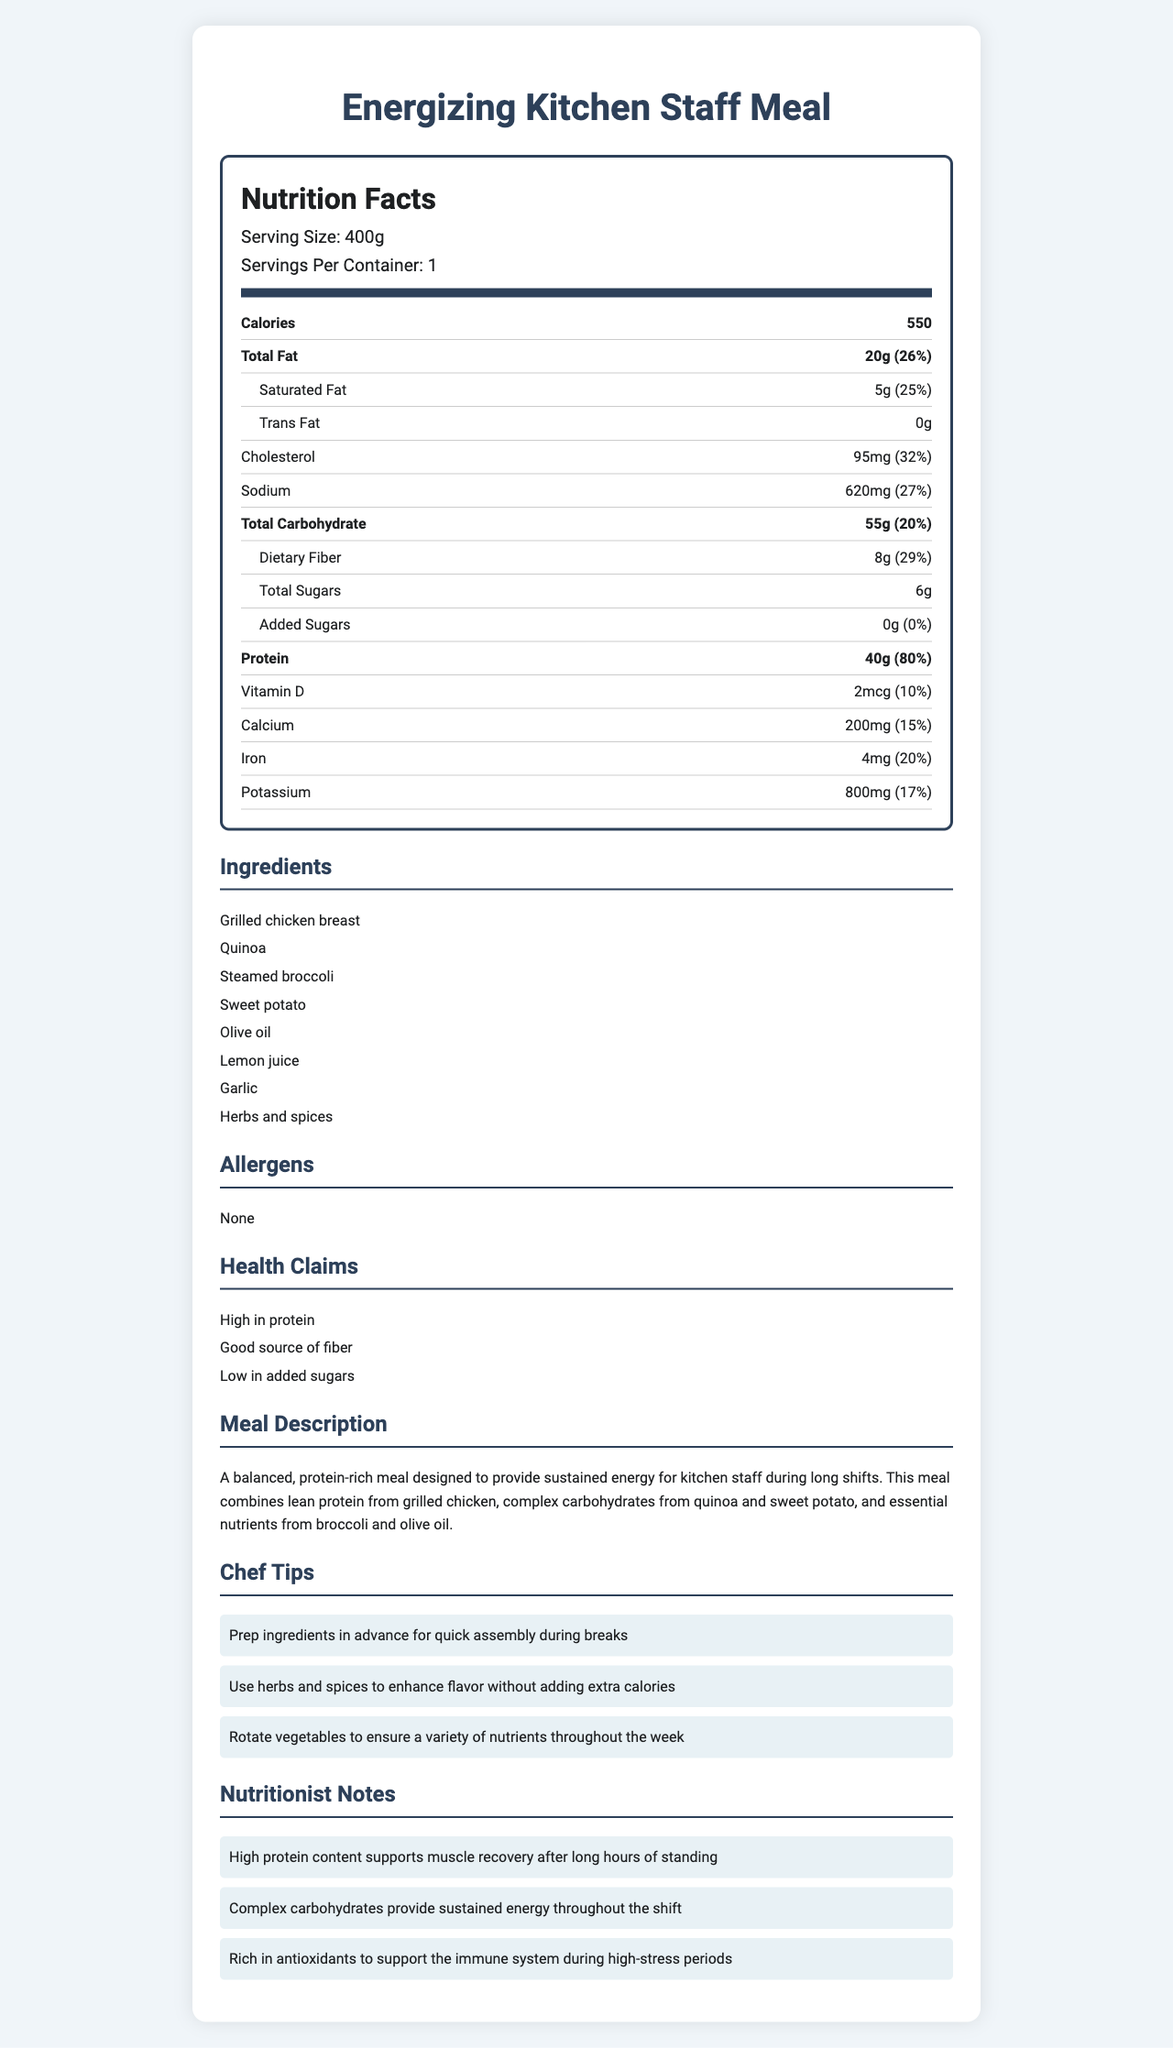what is the serving size? The document lists the serving size as 400g in the "Nutrition Facts" section.
Answer: 400g how many calories are in one serving? According to the "Nutrition Facts" section, there are 550 calories per serving.
Answer: 550 calories what is the total amount of protein in the meal? The "Nutrition Facts" section mentions that the meal contains 40g of protein.
Answer: 40g how much dietary fiber does the meal provide? The meal contains 8g of dietary fiber as per the "Nutrition Facts" section.
Answer: 8g what are the primary sources of protein in the meal? The "Ingredients" section indicates that grilled chicken breast is a major component, providing a significant source of protein.
Answer: Grilled chicken breast how much saturated fat is in the meal? The "Nutrition Facts" section specifies that the meal contains 5g of saturated fat.
Answer: 5g what is the daily value percentage of sodium? A. 15% B. 20% C. 27% The "Nutrition Facts" section shows that the meal contains 27% of the daily value for sodium.
Answer: C. 27% which of the following ingredients is not part of the meal? I. Quinoa II. Brown rice III. Sweet potato IV. Olive oil The "Ingredients" section lists quinoa, sweet potato, and olive oil but does not mention brown rice.
Answer: II. Brown rice is this meal high in added sugars? The "Nutrition Facts" section indicates that the meal contains 0g of added sugars.
Answer: No is there any allergen listed for this meal? The "Allergens" section states "None", meaning the meal contains no listed allergens.
Answer: No summarize the main idea of the document. The document describes the "Energizing Kitchen Staff Meal," highlighting its high protein content and balanced nutrient profile to support sustained energy for long shifts. It includes detailed nutrition facts, ingredients, health claims, and tips from chefs and nutritionists.
Answer: A balanced, protein-rich meal designed for kitchen staff. what is the ingredient responsible for the high protein content? While grilled chicken breast is a likely candidate, the document does not provide specific amounts for each ingredient, making it impossible to determine the exact source of high protein content.
Answer: Cannot be determined 